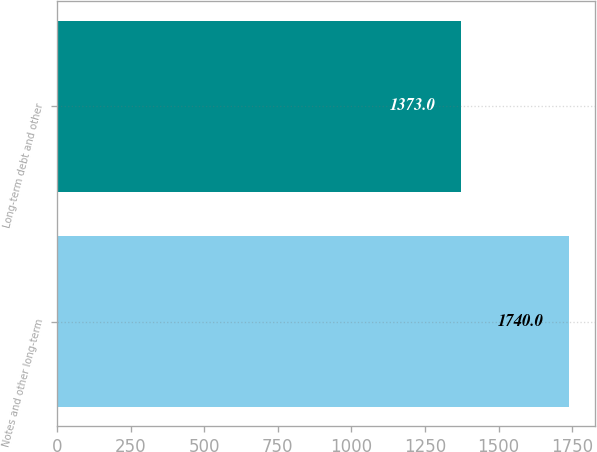Convert chart to OTSL. <chart><loc_0><loc_0><loc_500><loc_500><bar_chart><fcel>Notes and other long-term<fcel>Long-term debt and other<nl><fcel>1740<fcel>1373<nl></chart> 